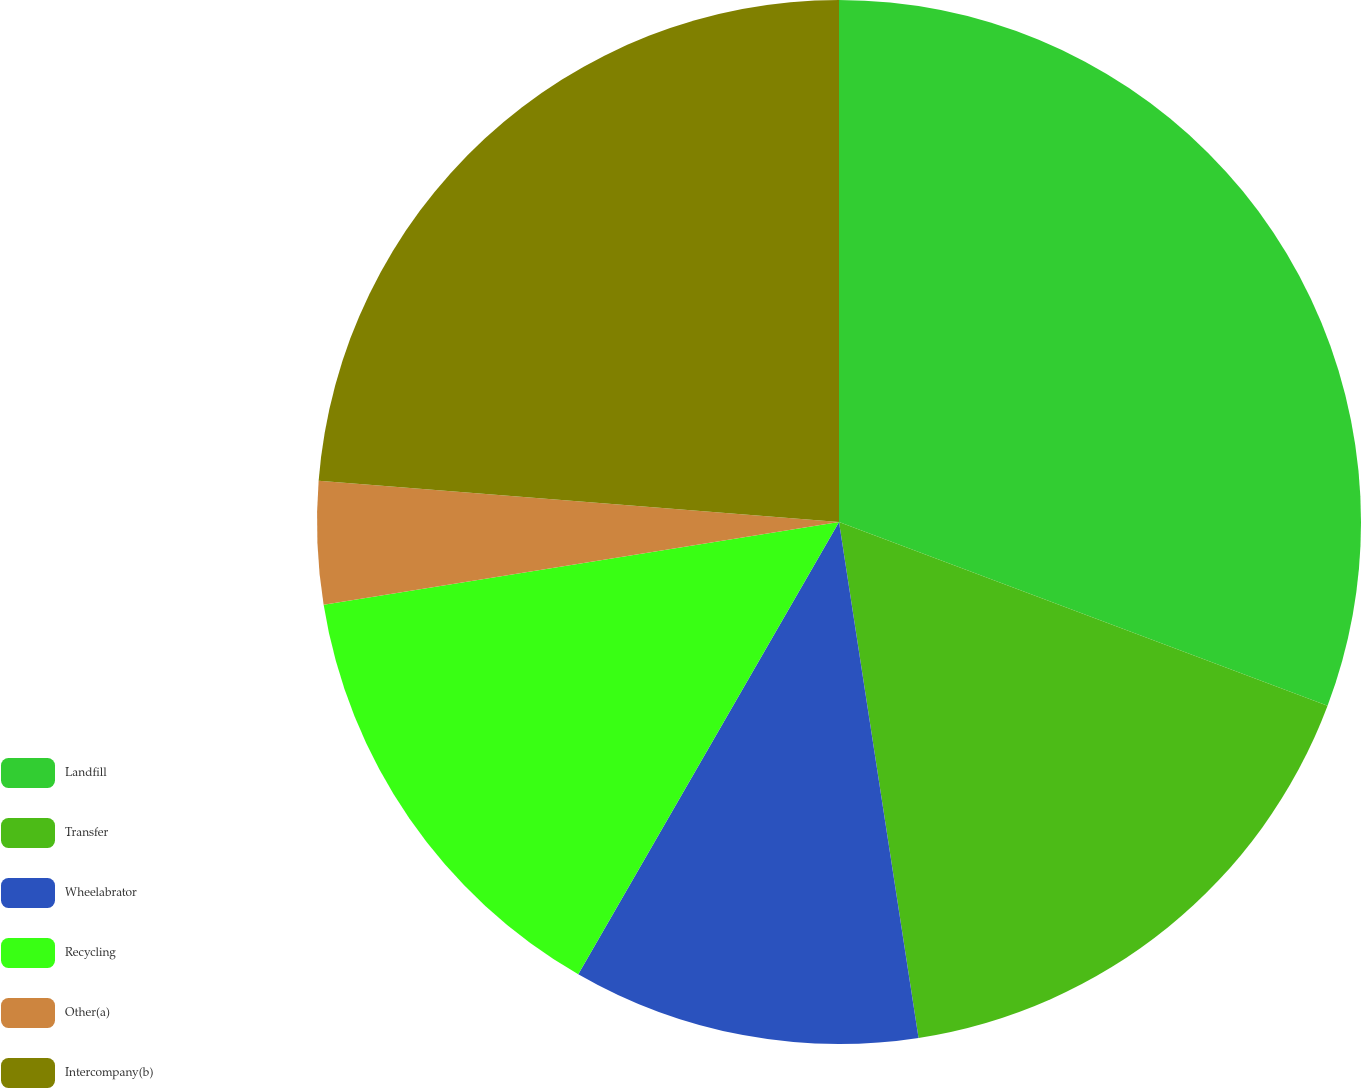Convert chart to OTSL. <chart><loc_0><loc_0><loc_500><loc_500><pie_chart><fcel>Landfill<fcel>Transfer<fcel>Wheelabrator<fcel>Recycling<fcel>Other(a)<fcel>Intercompany(b)<nl><fcel>30.73%<fcel>16.84%<fcel>10.76%<fcel>14.14%<fcel>3.8%<fcel>23.74%<nl></chart> 